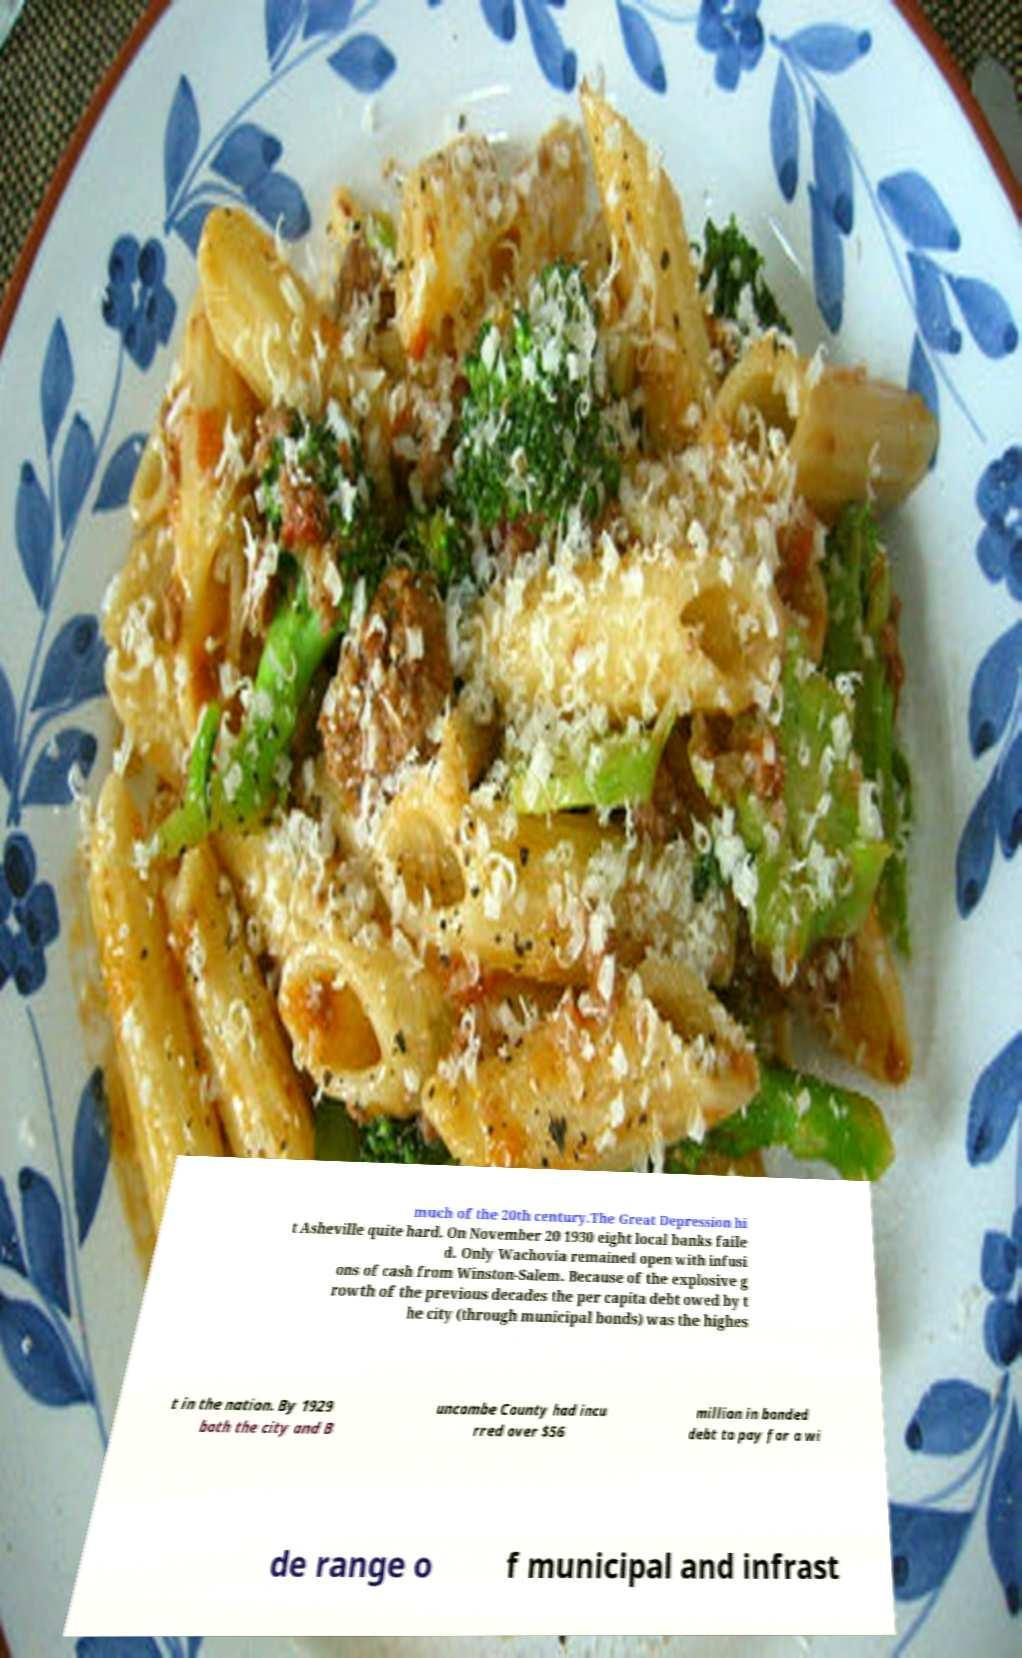Please read and relay the text visible in this image. What does it say? much of the 20th century.The Great Depression hi t Asheville quite hard. On November 20 1930 eight local banks faile d. Only Wachovia remained open with infusi ons of cash from Winston-Salem. Because of the explosive g rowth of the previous decades the per capita debt owed by t he city (through municipal bonds) was the highes t in the nation. By 1929 both the city and B uncombe County had incu rred over $56 million in bonded debt to pay for a wi de range o f municipal and infrast 